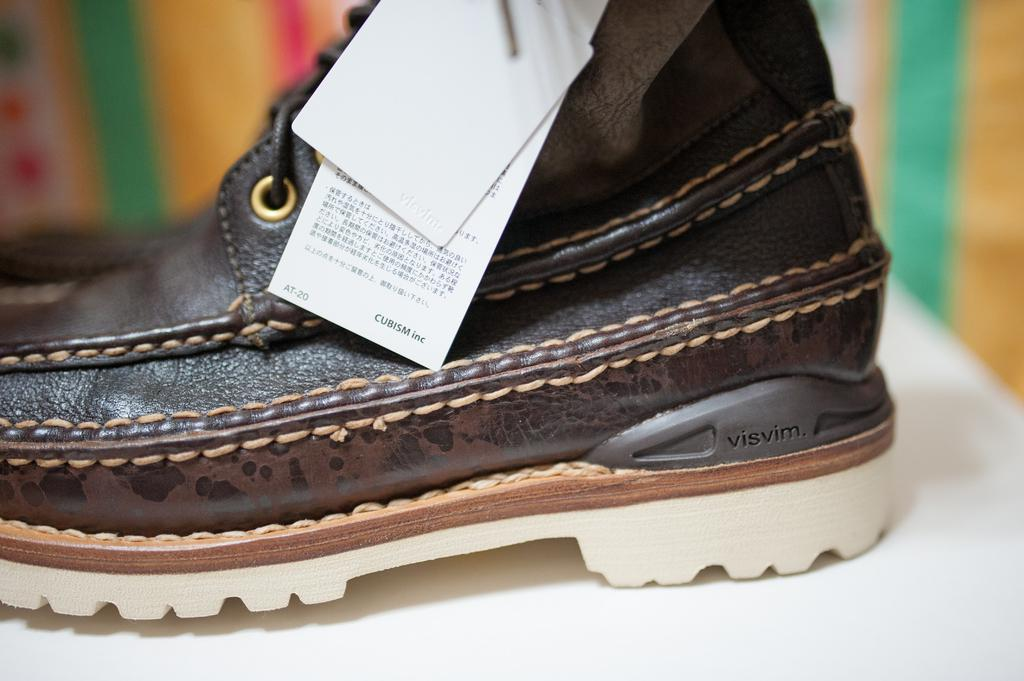What object is the main subject of the image? There is a shoe in the image. Is there any additional information about the shoe? Yes, the shoe has a tag. Can you describe the background of the image? The background of the image is blurry. What type of stamp can be seen on the shoe in the image? There is no stamp visible on the shoe in the image. How many people are present in the image? There is no group of people present in the image; it only features a shoe. What part of the human body is visible in the image? There is no part of the human body visible in the image; it only features a shoe. 